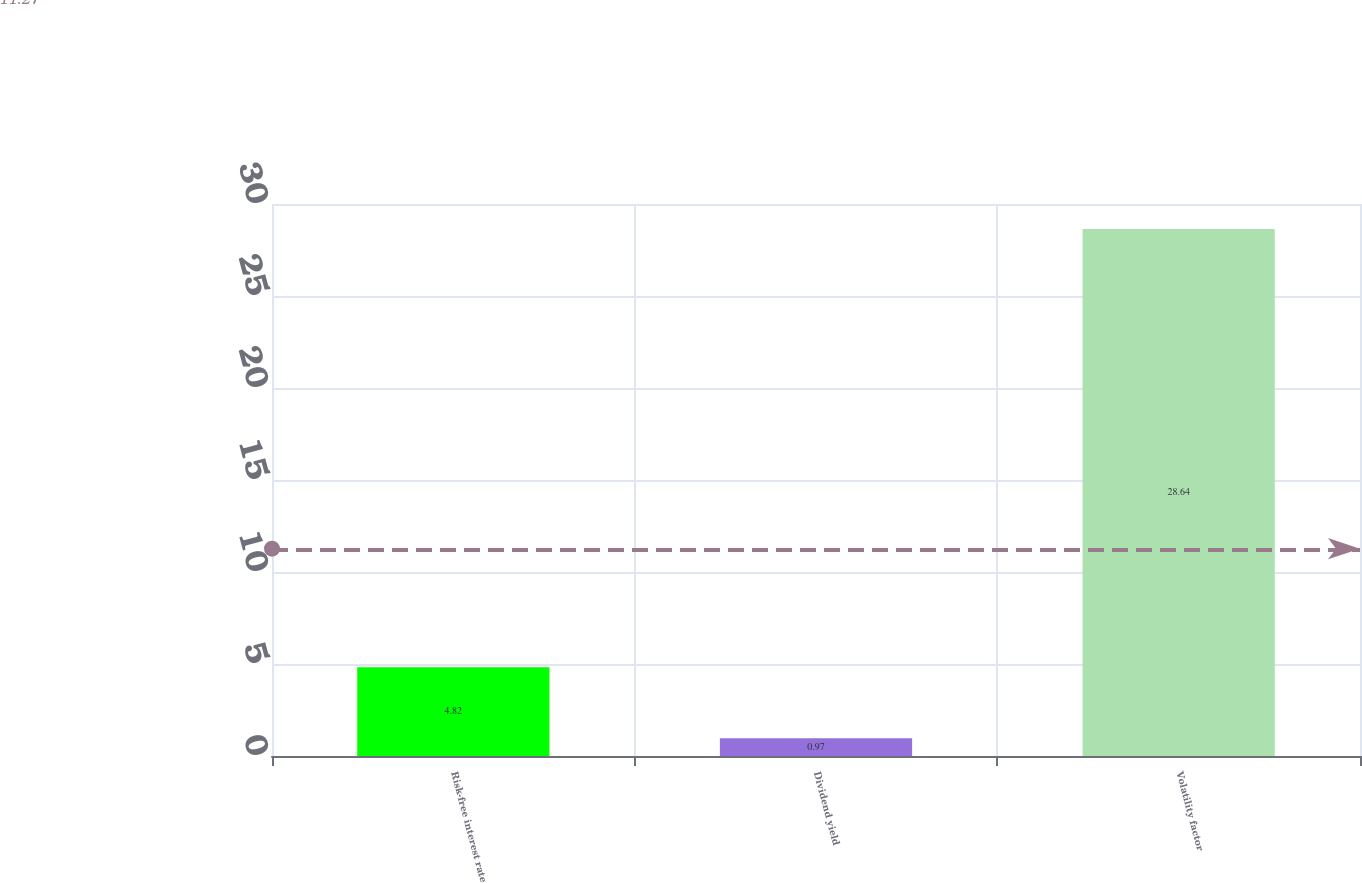Convert chart to OTSL. <chart><loc_0><loc_0><loc_500><loc_500><bar_chart><fcel>Risk-free interest rate<fcel>Dividend yield<fcel>Volatility factor<nl><fcel>4.82<fcel>0.97<fcel>28.64<nl></chart> 